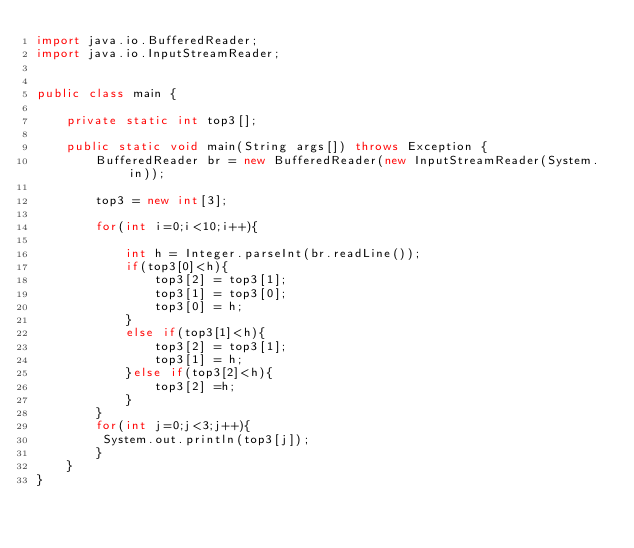Convert code to text. <code><loc_0><loc_0><loc_500><loc_500><_Java_>import java.io.BufferedReader;
import java.io.InputStreamReader;


public class main {

	private static int top3[];

	public static void main(String args[]) throws Exception {
		BufferedReader br = new BufferedReader(new InputStreamReader(System.in));

		top3 = new int[3];

		for(int i=0;i<10;i++){
			
			int h = Integer.parseInt(br.readLine());
			if(top3[0]<h){
				top3[2] = top3[1];
				top3[1] = top3[0];
				top3[0] = h;
			}
			else if(top3[1]<h){
				top3[2] = top3[1];
				top3[1] = h;
			}else if(top3[2]<h){
				top3[2] =h;
			}
		}
		for(int j=0;j<3;j++){
		 System.out.println(top3[j]);
		}
	}
}</code> 